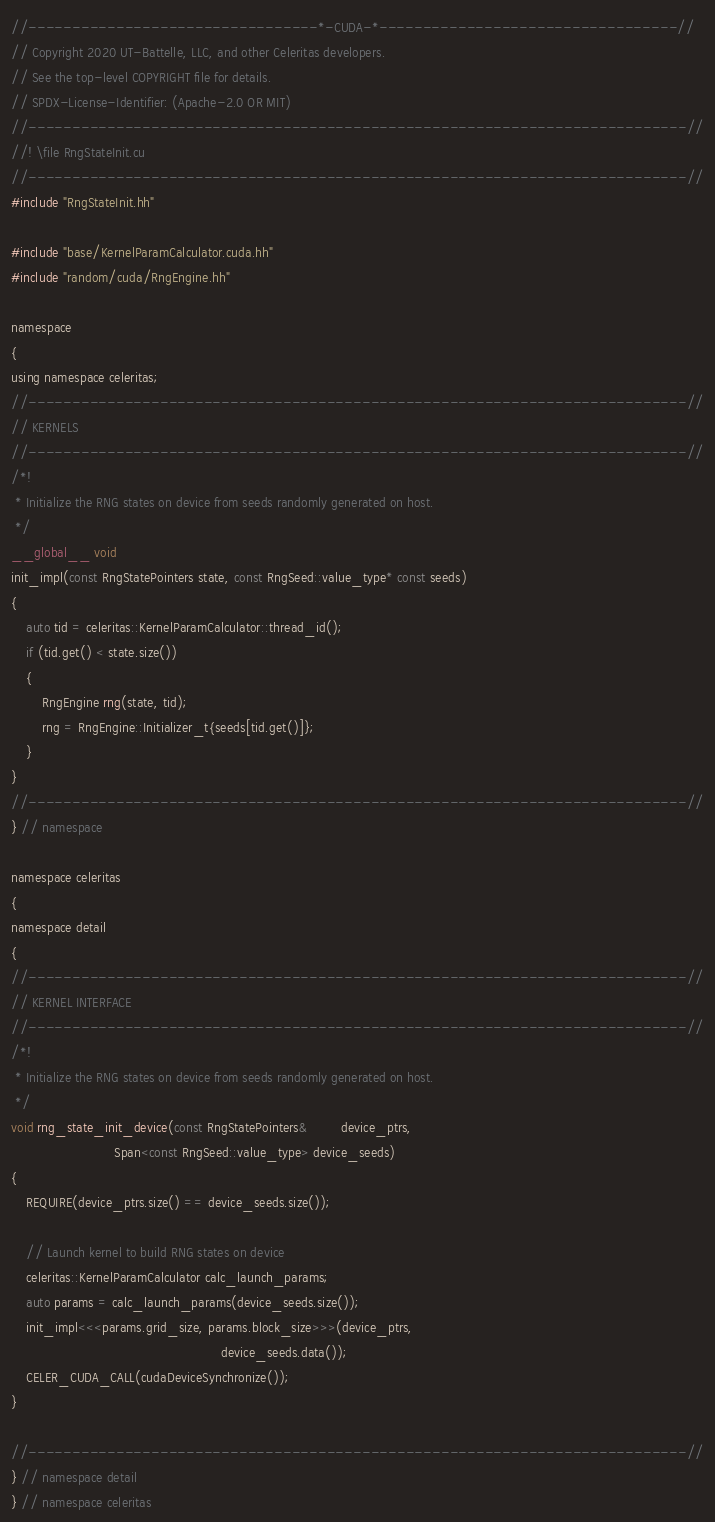<code> <loc_0><loc_0><loc_500><loc_500><_Cuda_>//---------------------------------*-CUDA-*----------------------------------//
// Copyright 2020 UT-Battelle, LLC, and other Celeritas developers.
// See the top-level COPYRIGHT file for details.
// SPDX-License-Identifier: (Apache-2.0 OR MIT)
//---------------------------------------------------------------------------//
//! \file RngStateInit.cu
//---------------------------------------------------------------------------//
#include "RngStateInit.hh"

#include "base/KernelParamCalculator.cuda.hh"
#include "random/cuda/RngEngine.hh"

namespace
{
using namespace celeritas;
//---------------------------------------------------------------------------//
// KERNELS
//---------------------------------------------------------------------------//
/*!
 * Initialize the RNG states on device from seeds randomly generated on host.
 */
__global__ void
init_impl(const RngStatePointers state, const RngSeed::value_type* const seeds)
{
    auto tid = celeritas::KernelParamCalculator::thread_id();
    if (tid.get() < state.size())
    {
        RngEngine rng(state, tid);
        rng = RngEngine::Initializer_t{seeds[tid.get()]};
    }
}
//---------------------------------------------------------------------------//
} // namespace

namespace celeritas
{
namespace detail
{
//---------------------------------------------------------------------------//
// KERNEL INTERFACE
//---------------------------------------------------------------------------//
/*!
 * Initialize the RNG states on device from seeds randomly generated on host.
 */
void rng_state_init_device(const RngStatePointers&         device_ptrs,
                           Span<const RngSeed::value_type> device_seeds)
{
    REQUIRE(device_ptrs.size() == device_seeds.size());

    // Launch kernel to build RNG states on device
    celeritas::KernelParamCalculator calc_launch_params;
    auto params = calc_launch_params(device_seeds.size());
    init_impl<<<params.grid_size, params.block_size>>>(device_ptrs,
                                                       device_seeds.data());
    CELER_CUDA_CALL(cudaDeviceSynchronize());
}

//---------------------------------------------------------------------------//
} // namespace detail
} // namespace celeritas
</code> 